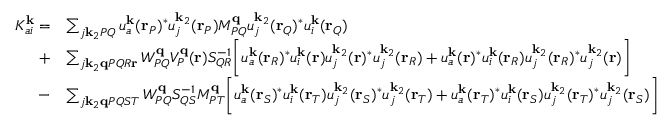<formula> <loc_0><loc_0><loc_500><loc_500>\begin{array} { r l } { K _ { a i } ^ { k } = } & { \sum _ { j k _ { 2 } P Q } u _ { a } ^ { k } ( r _ { P } ) ^ { * } u _ { j } ^ { k _ { 2 } } ( r _ { P } ) M _ { P Q } ^ { q } u _ { j } ^ { k _ { 2 } } ( r _ { Q } ) ^ { * } u _ { i } ^ { k } ( r _ { Q } ) } \\ { + } & { \sum _ { j k _ { 2 } q P Q R r } W _ { P Q } ^ { q } V _ { P } ^ { q } ( r ) S _ { Q R } ^ { - 1 } \left [ u _ { a } ^ { k } ( r _ { R } ) ^ { * } u _ { i } ^ { k } ( r ) u _ { j } ^ { k _ { 2 } } ( r ) ^ { * } u _ { j } ^ { k _ { 2 } } ( r _ { R } ) + u _ { a } ^ { k } ( r ) ^ { * } u _ { i } ^ { k } ( r _ { R } ) u _ { j } ^ { k _ { 2 } } ( r _ { R } ) ^ { * } u _ { j } ^ { k _ { 2 } } ( r ) \right ] } \\ { - } & { \sum _ { j k _ { 2 } q P Q S T } W _ { P Q } ^ { q } S _ { Q S } ^ { - 1 } M _ { P T } ^ { q } \left [ u _ { a } ^ { k } ( r _ { S } ) ^ { * } u _ { i } ^ { k } ( r _ { T } ) u _ { j } ^ { k _ { 2 } } ( r _ { S } ) ^ { * } u _ { j } ^ { k _ { 2 } } ( r _ { T } ) + u _ { a } ^ { k } ( r _ { T } ) ^ { * } u _ { i } ^ { k } ( r _ { S } ) u _ { j } ^ { k _ { 2 } } ( r _ { T } ) ^ { * } u _ { j } ^ { k _ { 2 } } ( r _ { S } ) \right ] } \end{array}</formula> 